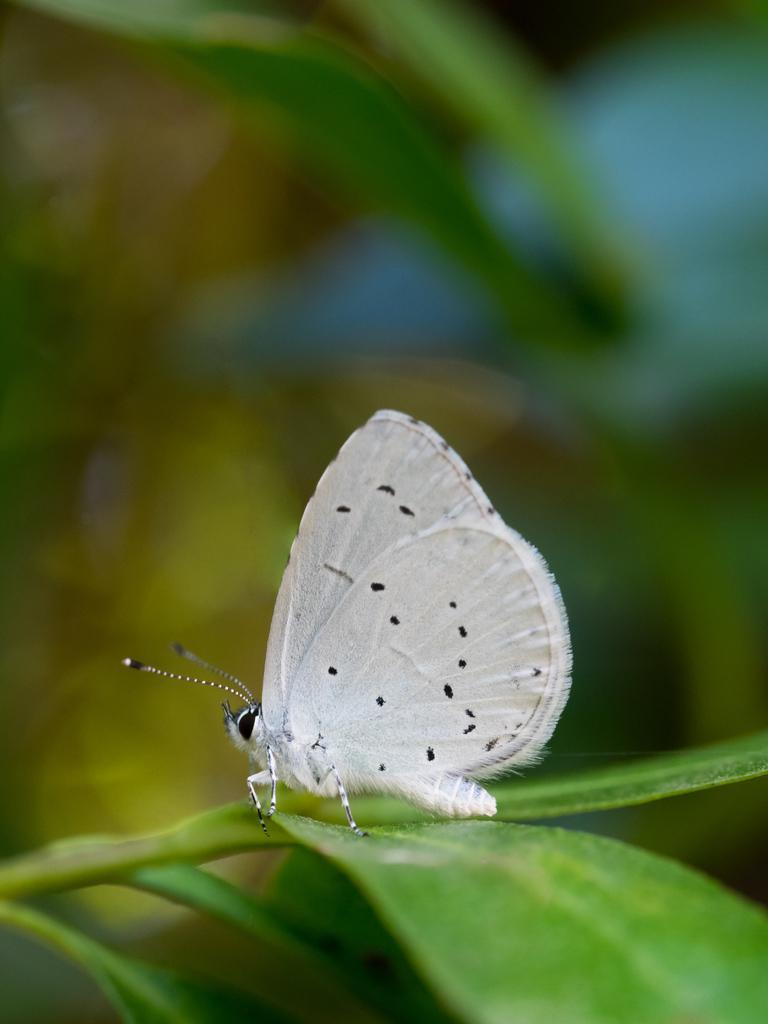In one or two sentences, can you explain what this image depicts? In the picture we can see a white butterfly sitting on the plant and behind it we can see some plants which are not clearly visible. 